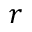Convert formula to latex. <formula><loc_0><loc_0><loc_500><loc_500>r</formula> 